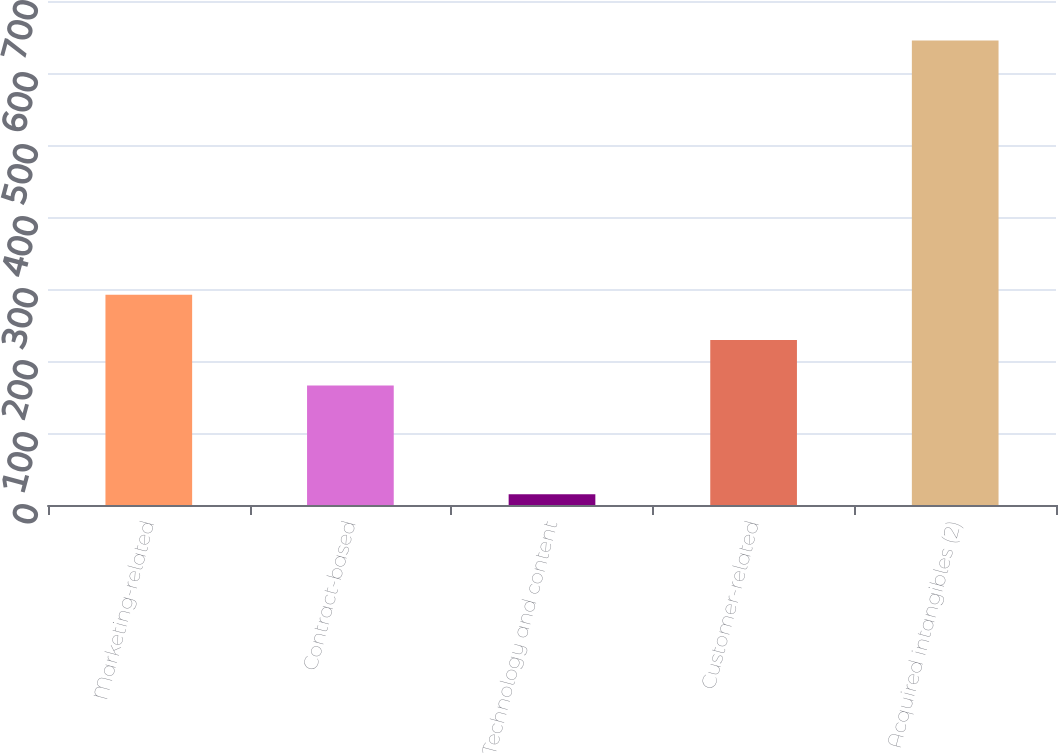<chart> <loc_0><loc_0><loc_500><loc_500><bar_chart><fcel>Marketing-related<fcel>Contract-based<fcel>Technology and content<fcel>Customer-related<fcel>Acquired intangibles (2)<nl><fcel>292<fcel>166<fcel>15<fcel>229<fcel>645<nl></chart> 